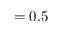<formula> <loc_0><loc_0><loc_500><loc_500>= 0 . 5</formula> 